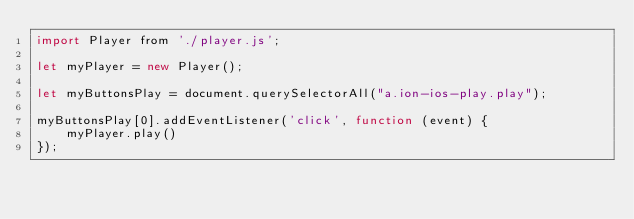Convert code to text. <code><loc_0><loc_0><loc_500><loc_500><_JavaScript_>import Player from './player.js';

let myPlayer = new Player();

let myButtonsPlay = document.querySelectorAll("a.ion-ios-play.play");

myButtonsPlay[0].addEventListener('click', function (event) {
    myPlayer.play()
});



</code> 